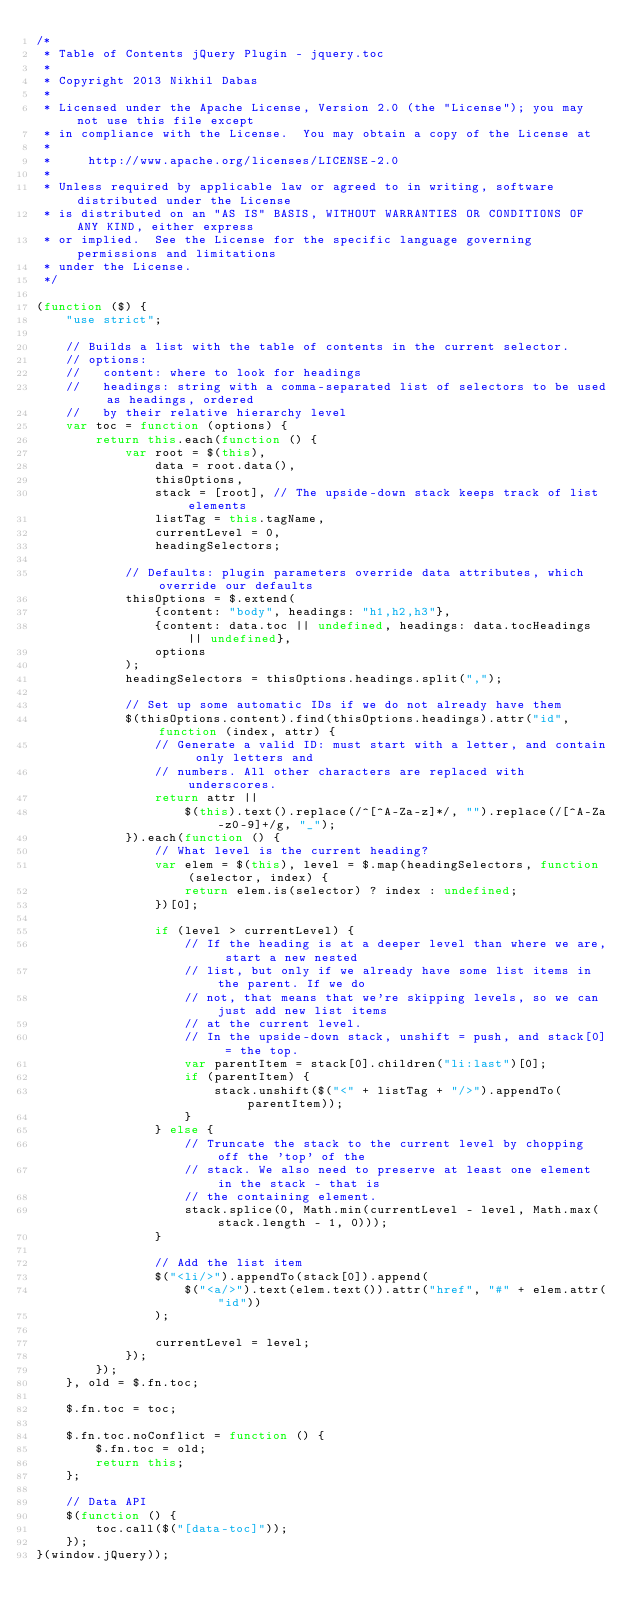<code> <loc_0><loc_0><loc_500><loc_500><_JavaScript_>/*
 * Table of Contents jQuery Plugin - jquery.toc
 *
 * Copyright 2013 Nikhil Dabas
 * 
 * Licensed under the Apache License, Version 2.0 (the "License"); you may not use this file except
 * in compliance with the License.  You may obtain a copy of the License at
 *
 *     http://www.apache.org/licenses/LICENSE-2.0
 *
 * Unless required by applicable law or agreed to in writing, software distributed under the License
 * is distributed on an "AS IS" BASIS, WITHOUT WARRANTIES OR CONDITIONS OF ANY KIND, either express
 * or implied.  See the License for the specific language governing permissions and limitations
 * under the License.
 */

(function ($) {
    "use strict";

    // Builds a list with the table of contents in the current selector.
    // options:
    //   content: where to look for headings
    //   headings: string with a comma-separated list of selectors to be used as headings, ordered
    //   by their relative hierarchy level
    var toc = function (options) {
        return this.each(function () {
            var root = $(this),
                data = root.data(),
                thisOptions,
                stack = [root], // The upside-down stack keeps track of list elements
                listTag = this.tagName,
                currentLevel = 0,
                headingSelectors;

            // Defaults: plugin parameters override data attributes, which override our defaults
            thisOptions = $.extend(
                {content: "body", headings: "h1,h2,h3"},
                {content: data.toc || undefined, headings: data.tocHeadings || undefined},
                options
            );
            headingSelectors = thisOptions.headings.split(",");

            // Set up some automatic IDs if we do not already have them
            $(thisOptions.content).find(thisOptions.headings).attr("id", function (index, attr) {
                // Generate a valid ID: must start with a letter, and contain only letters and
                // numbers. All other characters are replaced with underscores.
                return attr ||
                    $(this).text().replace(/^[^A-Za-z]*/, "").replace(/[^A-Za-z0-9]+/g, "_");
            }).each(function () {
                // What level is the current heading?
                var elem = $(this), level = $.map(headingSelectors, function (selector, index) {
                    return elem.is(selector) ? index : undefined;
                })[0];

                if (level > currentLevel) {
                    // If the heading is at a deeper level than where we are, start a new nested
                    // list, but only if we already have some list items in the parent. If we do
                    // not, that means that we're skipping levels, so we can just add new list items
                    // at the current level.
                    // In the upside-down stack, unshift = push, and stack[0] = the top.
                    var parentItem = stack[0].children("li:last")[0];
                    if (parentItem) {
                        stack.unshift($("<" + listTag + "/>").appendTo(parentItem));
                    }
                } else {
                    // Truncate the stack to the current level by chopping off the 'top' of the
                    // stack. We also need to preserve at least one element in the stack - that is
                    // the containing element.
                    stack.splice(0, Math.min(currentLevel - level, Math.max(stack.length - 1, 0)));
                }

                // Add the list item
                $("<li/>").appendTo(stack[0]).append(
                    $("<a/>").text(elem.text()).attr("href", "#" + elem.attr("id"))
                );

                currentLevel = level;
            });
        });
    }, old = $.fn.toc;

    $.fn.toc = toc;

    $.fn.toc.noConflict = function () {
        $.fn.toc = old;
        return this;
    };

    // Data API
    $(function () {
        toc.call($("[data-toc]"));
    });
}(window.jQuery));
</code> 